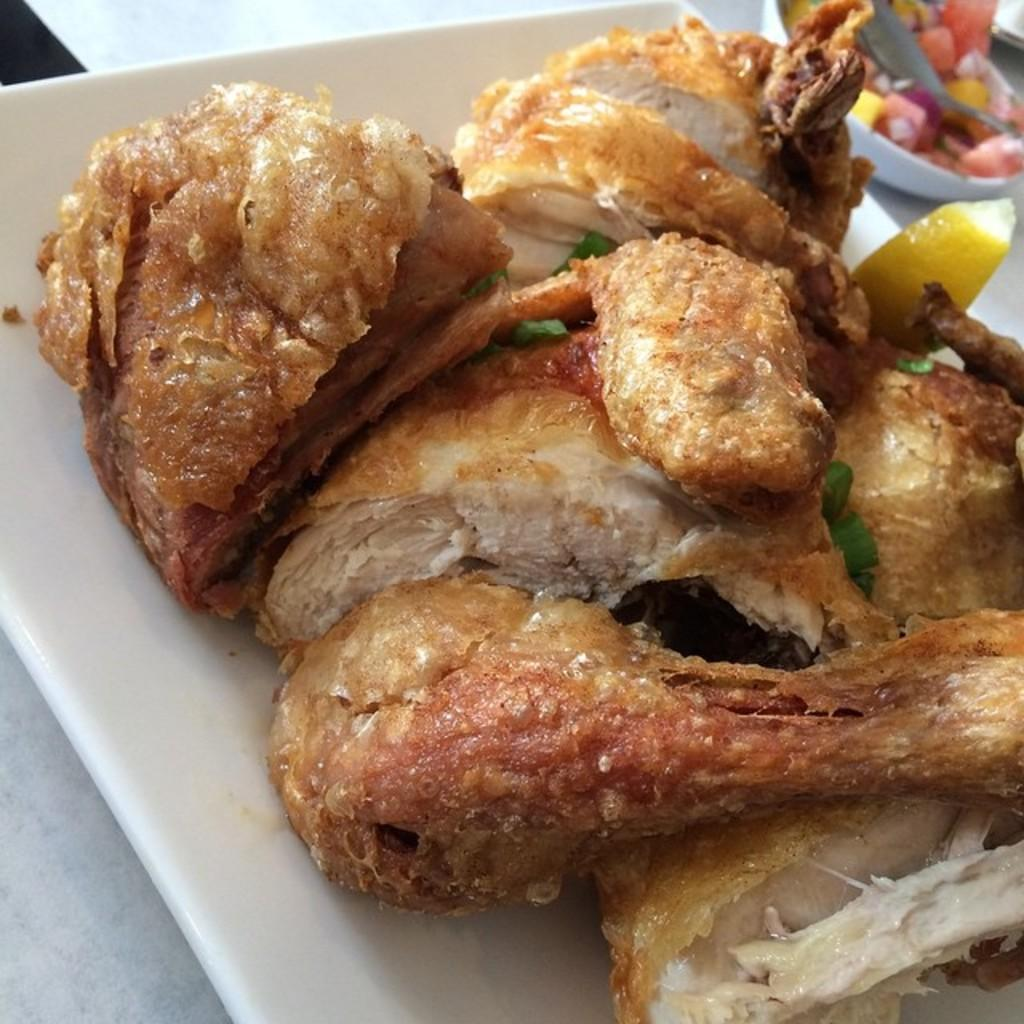What is located at the bottom of the image? There is a plate at the bottom of the image. What is on the plate? The plate contains food items. What can be seen in the background of the image? There is a bowl in the background of the image. What is in the bowl? The bowl contains fruits. What utensil is present in the bowl? There is a spoon in the bowl. What advice is given by the food items on the plate in the image? There is no advice given by the food items on the plate in the image, as they are inanimate objects. 